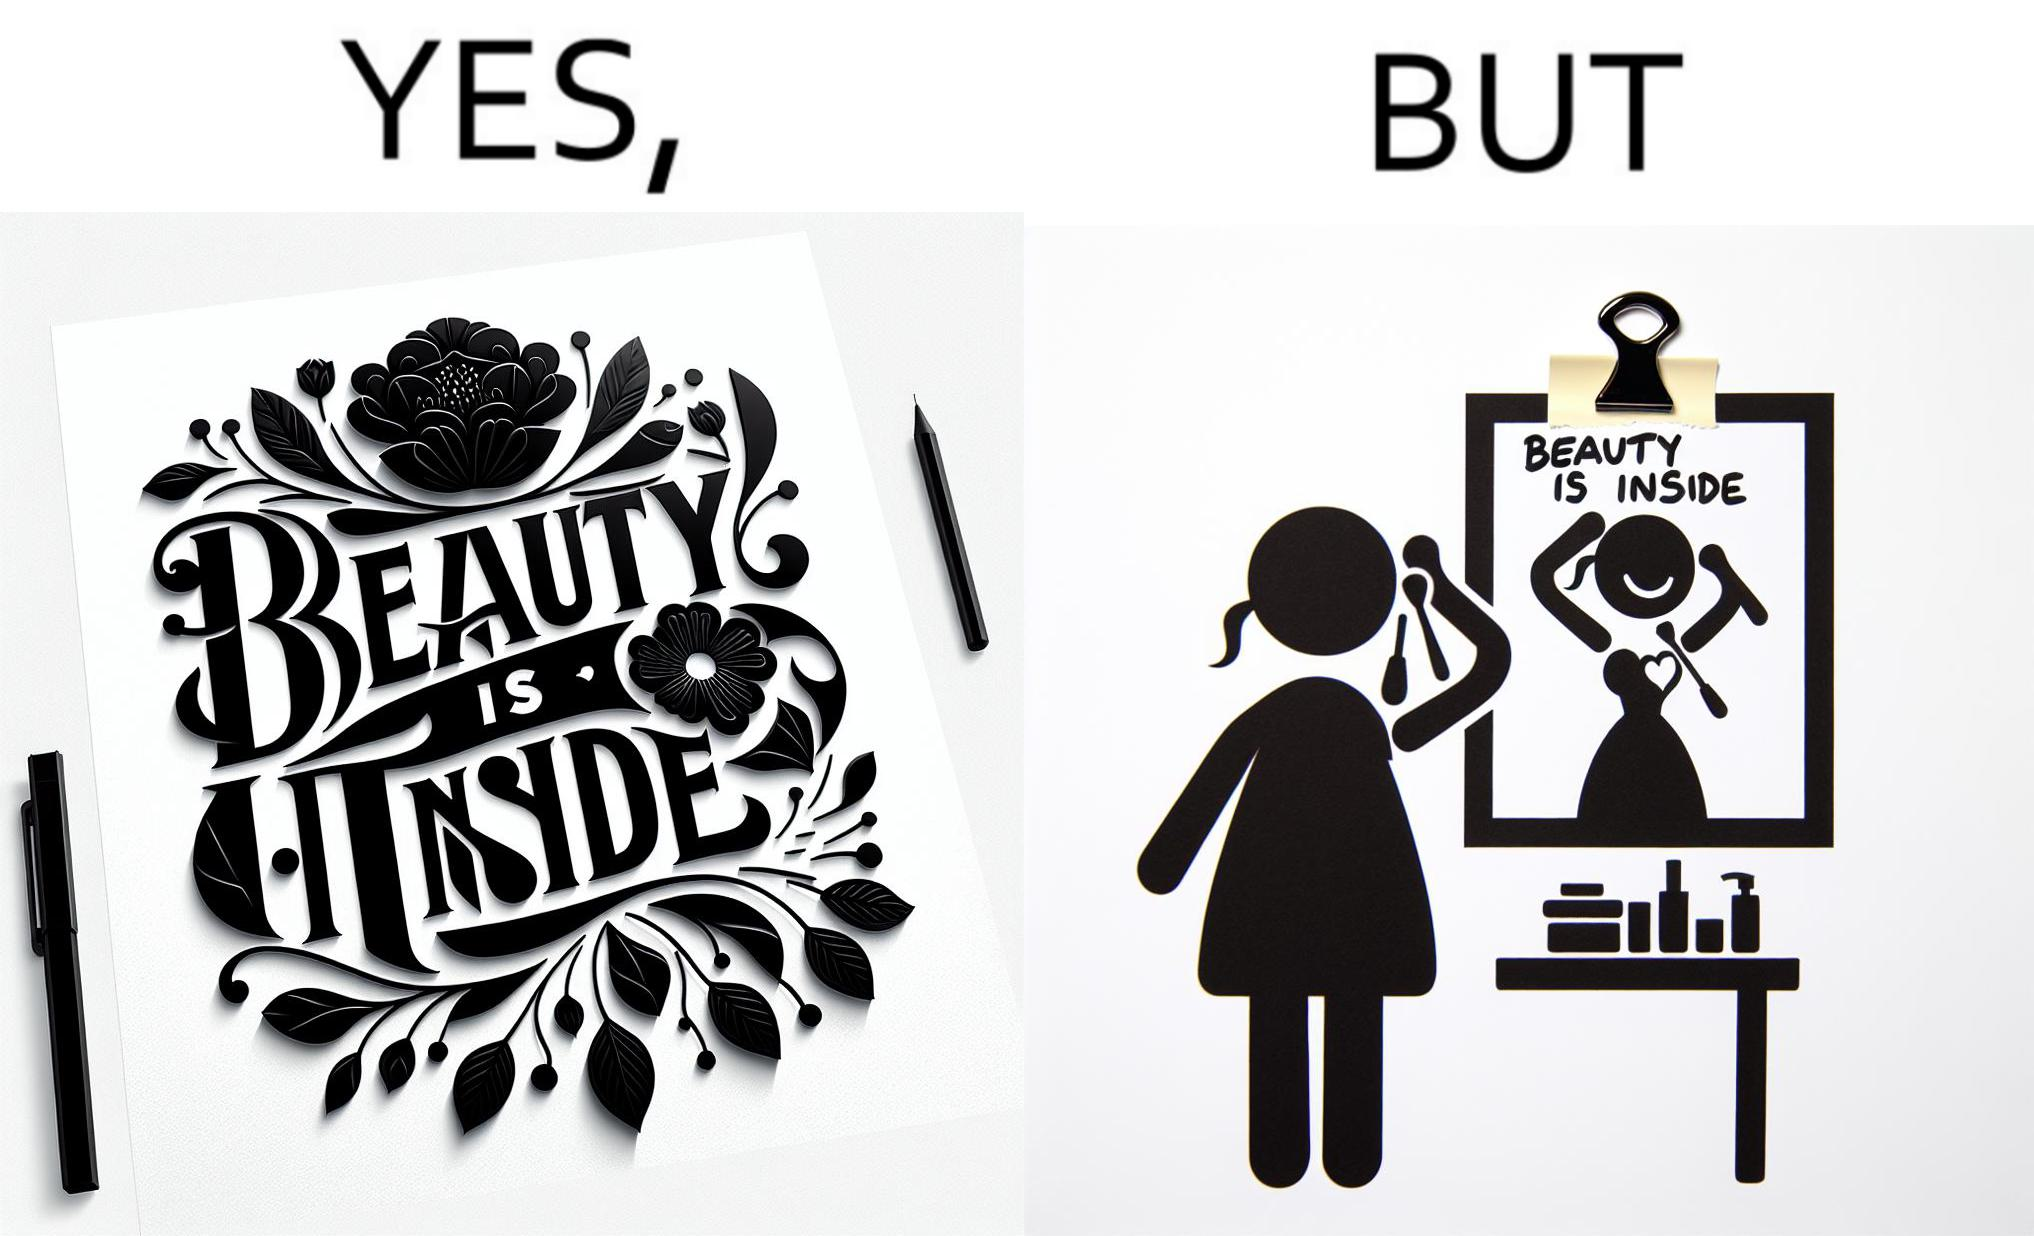Compare the left and right sides of this image. In the left part of the image: The image shows a text in beautiful font with flowers drawn around it. The text says "Beauty Is Inside". In the right part of the image: The image shows a woman applying makeup after shower by looking at herself in the dressing mirror. A piece of paper that says "Beauty is Inside" is clipped to the top of the mirror. 